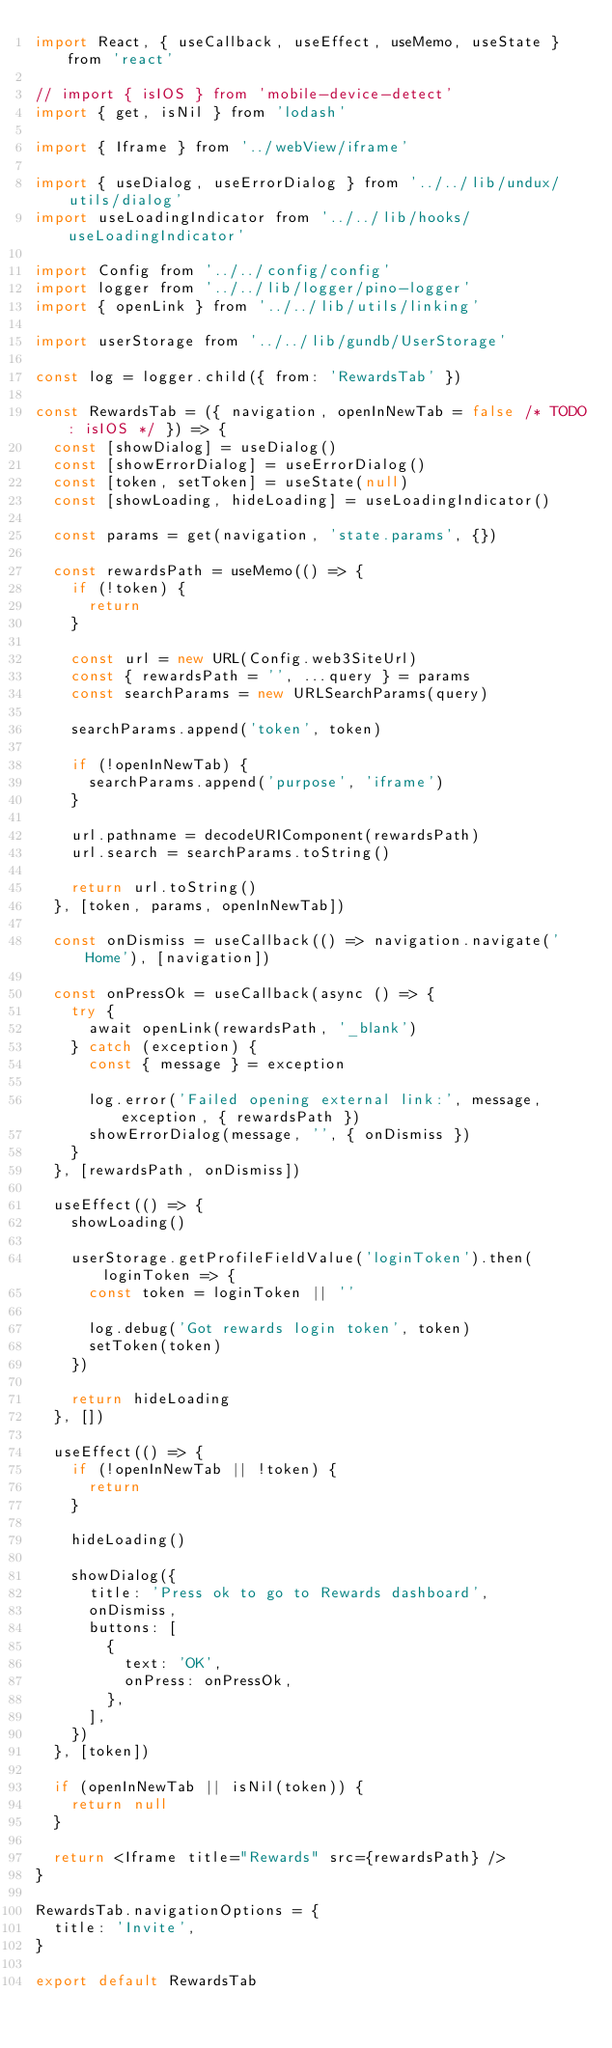Convert code to text. <code><loc_0><loc_0><loc_500><loc_500><_JavaScript_>import React, { useCallback, useEffect, useMemo, useState } from 'react'

// import { isIOS } from 'mobile-device-detect'
import { get, isNil } from 'lodash'

import { Iframe } from '../webView/iframe'

import { useDialog, useErrorDialog } from '../../lib/undux/utils/dialog'
import useLoadingIndicator from '../../lib/hooks/useLoadingIndicator'

import Config from '../../config/config'
import logger from '../../lib/logger/pino-logger'
import { openLink } from '../../lib/utils/linking'

import userStorage from '../../lib/gundb/UserStorage'

const log = logger.child({ from: 'RewardsTab' })

const RewardsTab = ({ navigation, openInNewTab = false /* TODO: isIOS */ }) => {
  const [showDialog] = useDialog()
  const [showErrorDialog] = useErrorDialog()
  const [token, setToken] = useState(null)
  const [showLoading, hideLoading] = useLoadingIndicator()

  const params = get(navigation, 'state.params', {})

  const rewardsPath = useMemo(() => {
    if (!token) {
      return
    }

    const url = new URL(Config.web3SiteUrl)
    const { rewardsPath = '', ...query } = params
    const searchParams = new URLSearchParams(query)

    searchParams.append('token', token)

    if (!openInNewTab) {
      searchParams.append('purpose', 'iframe')
    }

    url.pathname = decodeURIComponent(rewardsPath)
    url.search = searchParams.toString()

    return url.toString()
  }, [token, params, openInNewTab])

  const onDismiss = useCallback(() => navigation.navigate('Home'), [navigation])

  const onPressOk = useCallback(async () => {
    try {
      await openLink(rewardsPath, '_blank')
    } catch (exception) {
      const { message } = exception

      log.error('Failed opening external link:', message, exception, { rewardsPath })
      showErrorDialog(message, '', { onDismiss })
    }
  }, [rewardsPath, onDismiss])

  useEffect(() => {
    showLoading()

    userStorage.getProfileFieldValue('loginToken').then(loginToken => {
      const token = loginToken || ''

      log.debug('Got rewards login token', token)
      setToken(token)
    })

    return hideLoading
  }, [])

  useEffect(() => {
    if (!openInNewTab || !token) {
      return
    }

    hideLoading()

    showDialog({
      title: 'Press ok to go to Rewards dashboard',
      onDismiss,
      buttons: [
        {
          text: 'OK',
          onPress: onPressOk,
        },
      ],
    })
  }, [token])

  if (openInNewTab || isNil(token)) {
    return null
  }

  return <Iframe title="Rewards" src={rewardsPath} />
}

RewardsTab.navigationOptions = {
  title: 'Invite',
}

export default RewardsTab
</code> 